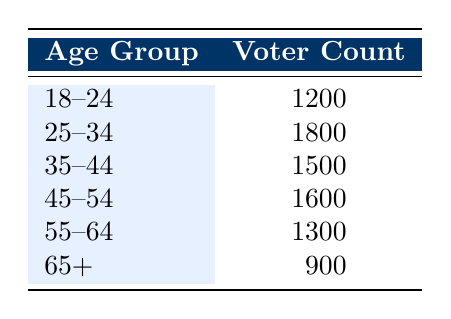What is the voter count for the age group 25-34? The table lists the voter count for the age group 25-34 as 1800.
Answer: 1800 Which age group has the highest voter count? By reviewing the voter counts, 25-34 has the highest count of 1800 compared to other age groups.
Answer: 25-34 What is the total number of voters from age groups 45-54 and 55-64 combined? To find this, we add the counts for these groups: 1600 (45-54) + 1300 (55-64) = 2900.
Answer: 2900 Is the voter count for the age group 18-24 greater than the voter count for the age group 65+? The count for 18-24 is 1200, while for 65+ it is 900. Since 1200 is greater than 900, the answer is yes.
Answer: Yes What is the average voter count across all age groups? To calculate the average, we first sum the voter counts: 1200 + 1800 + 1500 + 1600 + 1300 + 900 = 10300. There are 6 age groups, so the average is 10300 / 6 = 1716.67.
Answer: 1716.67 Which two age groups have the lowest voter turnout? Comparing all age group counts, 65+ has 900 and 18-24 has 1200, thus 65+ and 18-24 are the lowest.
Answer: 65+ and 18-24 What is the difference in voter count between the age groups 35-44 and 55-64? The count for 35-44 is 1500 and for 55-64 is 1300. The difference is calculated as 1500 - 1300 = 200.
Answer: 200 Is there an equal number of voters in the age groups 45-54 and 18-24? The counts are 1600 for 45-54 and 1200 for 18-24. Since 1600 does not equal 1200, the answer is no.
Answer: No What percentage of the total voter count does the age group 65+ represent? First, we find the total voter count, which is 10300. The count for 65+ is 900, so the percentage is (900 / 10300) * 100 = approximately 8.74%.
Answer: 8.74% 